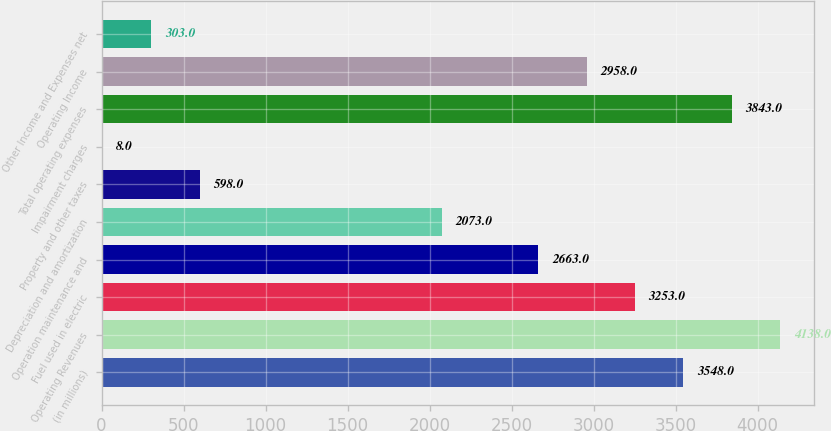<chart> <loc_0><loc_0><loc_500><loc_500><bar_chart><fcel>(in millions)<fcel>Operating Revenues<fcel>Fuel used in electric<fcel>Operation maintenance and<fcel>Depreciation and amortization<fcel>Property and other taxes<fcel>Impairment charges<fcel>Total operating expenses<fcel>Operating Income<fcel>Other Income and Expenses net<nl><fcel>3548<fcel>4138<fcel>3253<fcel>2663<fcel>2073<fcel>598<fcel>8<fcel>3843<fcel>2958<fcel>303<nl></chart> 